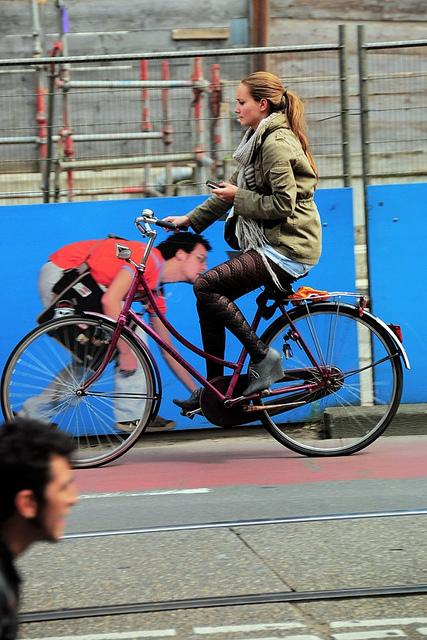What does the object use to speed?

Choices:
A) gas
B) gears
C) engine
D) fire gears 